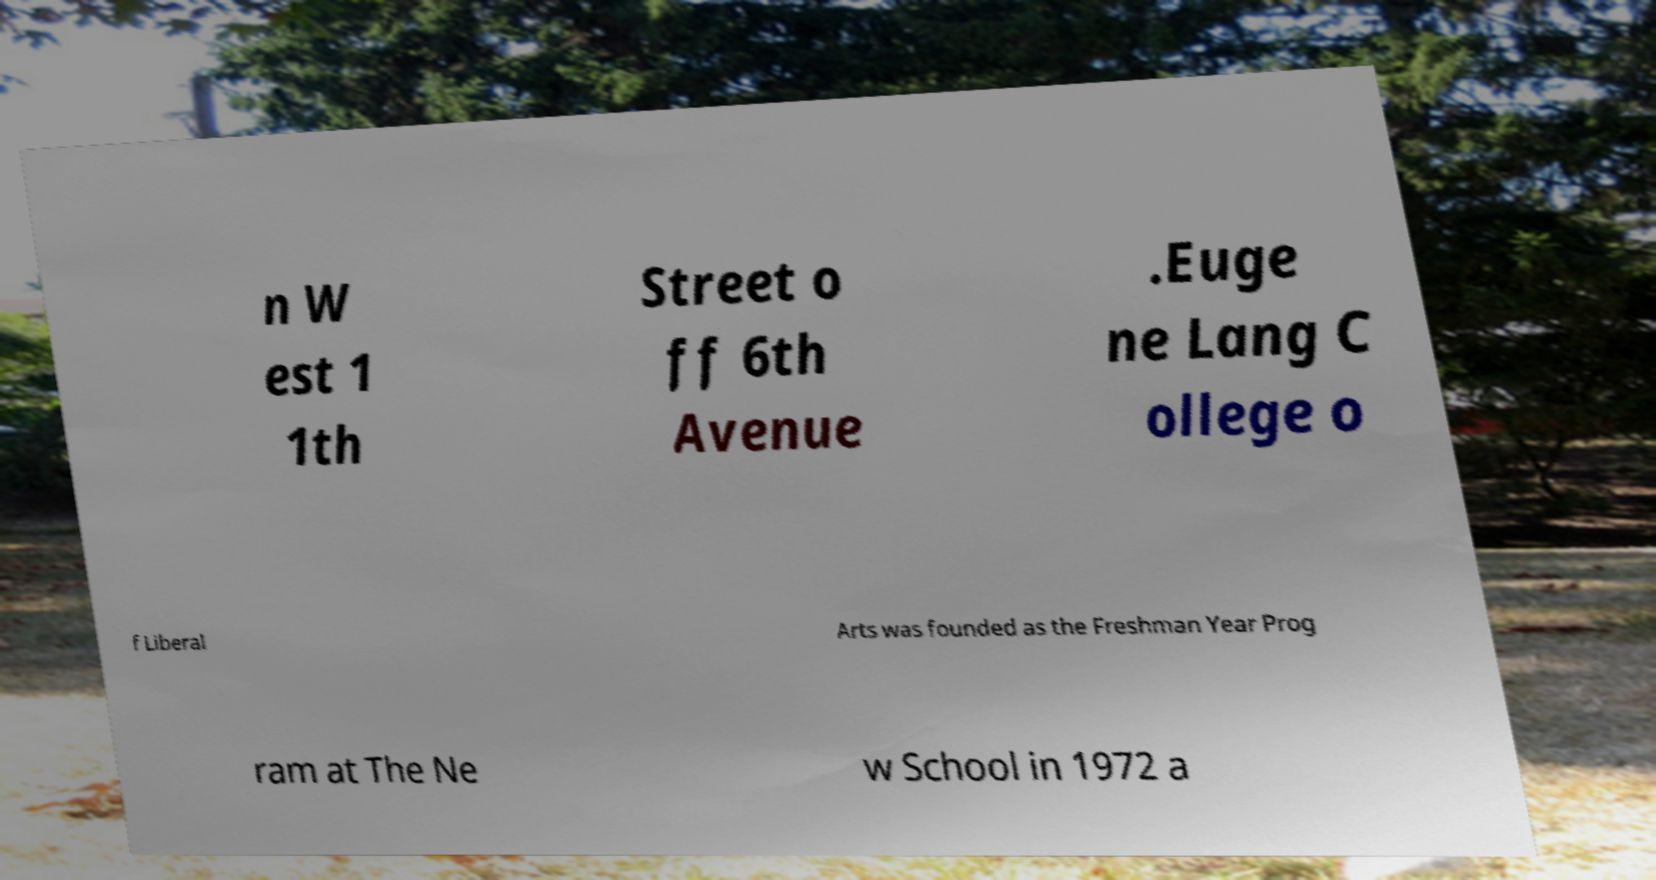Can you read and provide the text displayed in the image?This photo seems to have some interesting text. Can you extract and type it out for me? n W est 1 1th Street o ff 6th Avenue .Euge ne Lang C ollege o f Liberal Arts was founded as the Freshman Year Prog ram at The Ne w School in 1972 a 